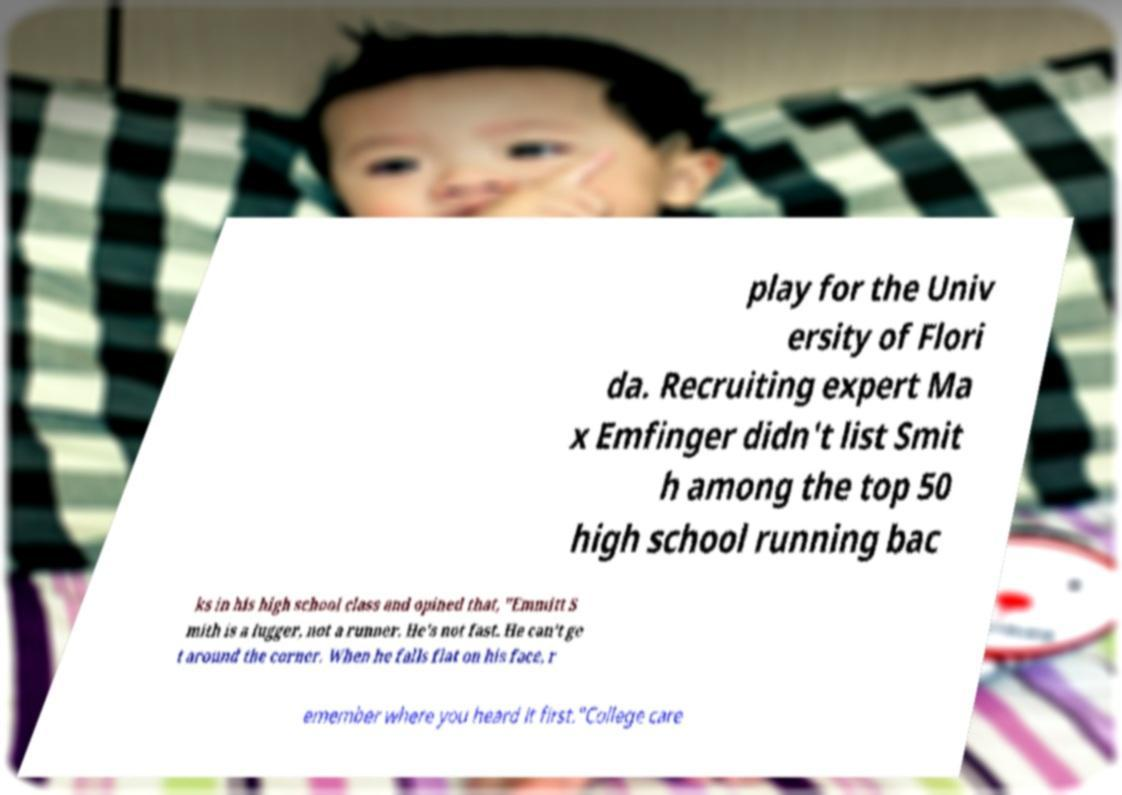Can you accurately transcribe the text from the provided image for me? play for the Univ ersity of Flori da. Recruiting expert Ma x Emfinger didn't list Smit h among the top 50 high school running bac ks in his high school class and opined that, "Emmitt S mith is a lugger, not a runner. He's not fast. He can't ge t around the corner. When he falls flat on his face, r emember where you heard it first."College care 